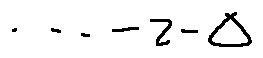<formula> <loc_0><loc_0><loc_500><loc_500>\cdots - z - \Delta</formula> 